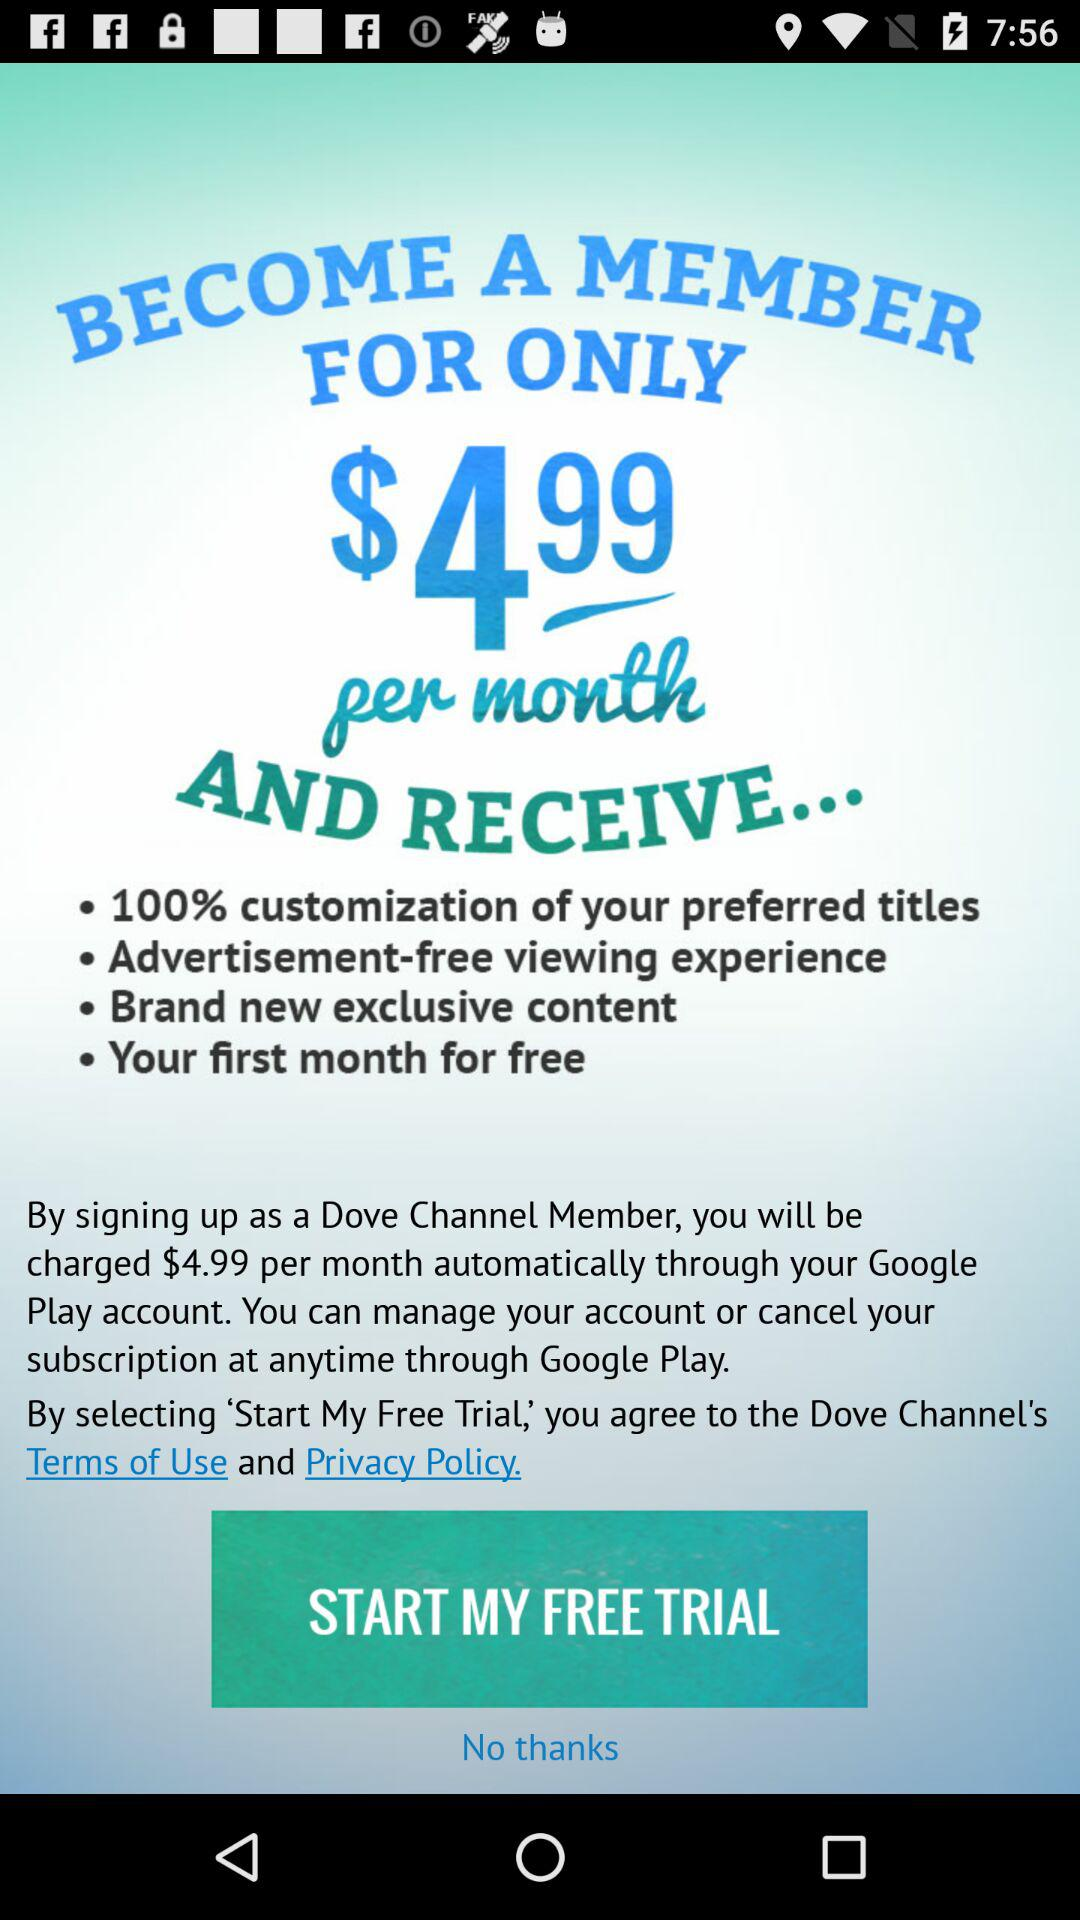How do we cancel the subscription?
When the provided information is insufficient, respond with <no answer>. <no answer> 